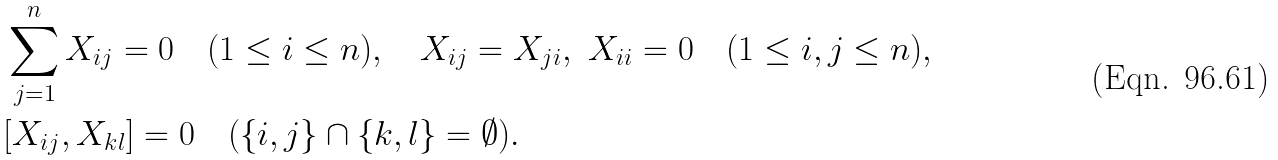<formula> <loc_0><loc_0><loc_500><loc_500>& \sum _ { j = 1 } ^ { n } X _ { i j } = 0 \quad ( 1 \leq i \leq n ) , \quad X _ { i j } = X _ { j i } , \ X _ { i i } = 0 \quad ( 1 \leq i , j \leq n ) , \\ & [ X _ { i j } , X _ { k l } ] = 0 \quad ( \{ i , j \} \cap \{ k , l \} = \emptyset ) .</formula> 